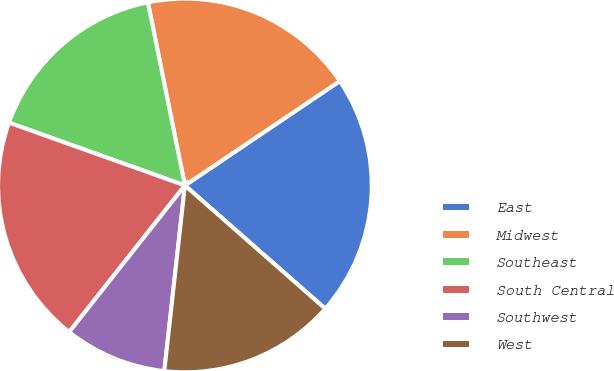Convert chart. <chart><loc_0><loc_0><loc_500><loc_500><pie_chart><fcel>East<fcel>Midwest<fcel>Southeast<fcel>South Central<fcel>Southwest<fcel>West<nl><fcel>20.91%<fcel>18.74%<fcel>16.37%<fcel>19.82%<fcel>8.88%<fcel>15.29%<nl></chart> 